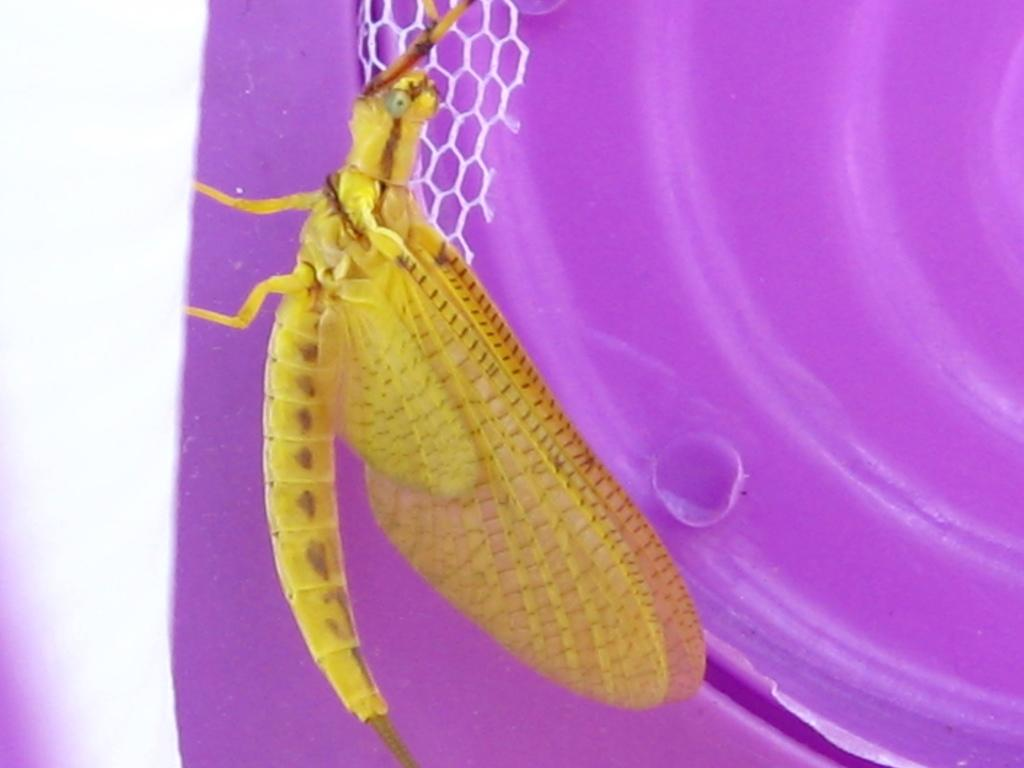What is the main subject of the image? There is an insect in the image. Where is the insect located in the image? The insect is in the center of the image. What else can be seen in the image besides the insect? There is a plastic object in the image. What type of smoke can be seen coming from the insect in the image? There is no smoke present in the image, and the insect is not producing any smoke. 